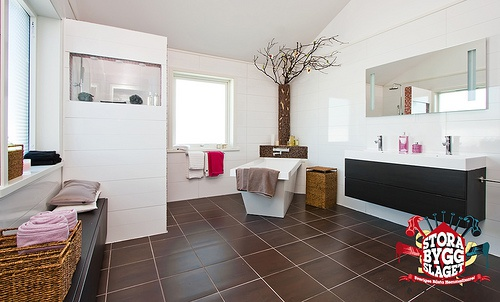Describe the objects in this image and their specific colors. I can see potted plant in lightpink, lightgray, darkgray, maroon, and gray tones, sink in lightpink, lightgray, black, and darkgray tones, and sink in lightpink, lightgray, darkgray, gray, and black tones in this image. 